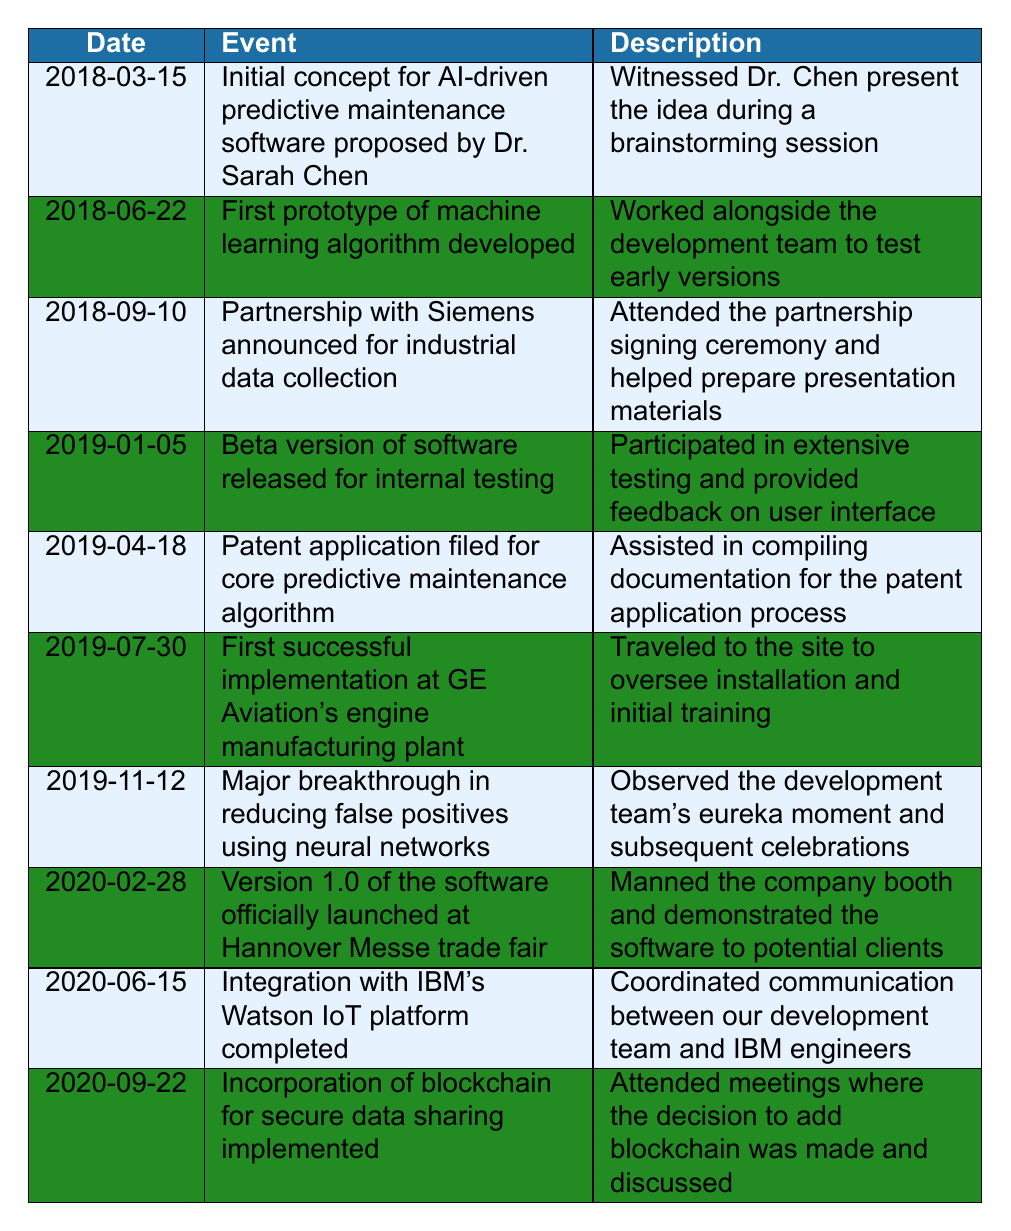What was the first event listed in the timeline? The first event in the timeline is dated March 15, 2018, where the initial concept for AI-driven predictive maintenance software was proposed by Dr. Sarah Chen. This is found in the first row of the table.
Answer: Initial concept for AI-driven predictive maintenance software proposed by Dr. Sarah Chen How many events occurred in the year 2019? By reviewing the dates listed in the table, the events for the year 2019 are: Beta version of software released on January 5, Patent application filed on April 18, First successful implementation on July 30, and Major breakthrough on November 12. Counting these events totals four occurrences in 2019.
Answer: 4 Was there a partnership formed with Siemens for industrial data collection? Yes, there was a partnership with Siemens announced on September 10, 2018. This is confirmed by the specific event listed in the table.
Answer: Yes What event occurred just before the official launch of Version 1.0 in 2020? The event just before the official launch of Version 1.0 on February 28, 2020, is the completion of the integration with IBM's Watson IoT platform on June 15, 2020. However, it is important to note that there is no event listed after the official launch until September 2020. The previous event before Version 1.0 launch is the Major breakthrough in false positives on November 12, 2019.
Answer: Major breakthrough in reducing false positives using neural networks How many months passed between the filing of the patent application and the first successful implementation at GE Aviation? The patent application was filed on April 18, 2019, and the first successful implementation occurred on July 30, 2019. Counting the months between these two dates includes April (1 month), May (2 months), June (3 months), and into July (4 months). Therefore, it is a little more than 3 months but not quite 4 full months, depending on the specific days in each month, we can say just over 3 months.
Answer: Just over 3 months 